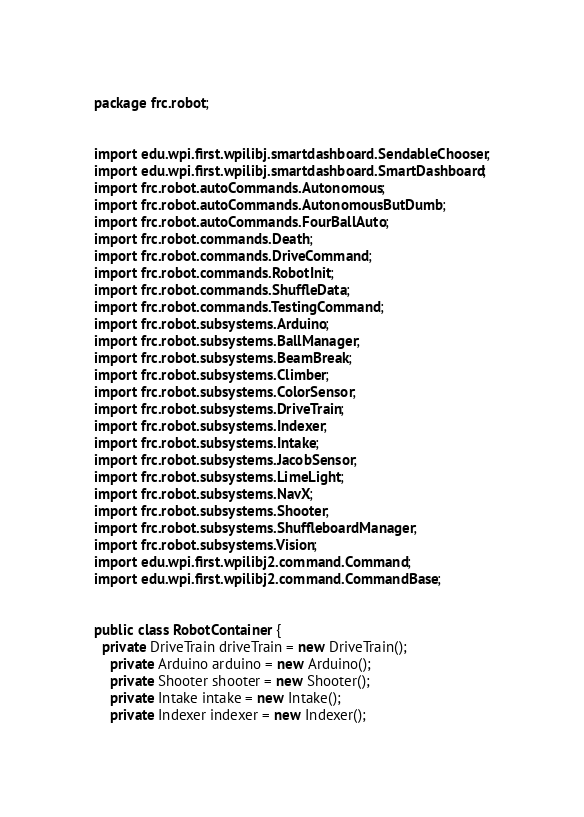Convert code to text. <code><loc_0><loc_0><loc_500><loc_500><_Java_>package frc.robot;


import edu.wpi.first.wpilibj.smartdashboard.SendableChooser;
import edu.wpi.first.wpilibj.smartdashboard.SmartDashboard;
import frc.robot.autoCommands.Autonomous;
import frc.robot.autoCommands.AutonomousButDumb;
import frc.robot.autoCommands.FourBallAuto;
import frc.robot.commands.Death;
import frc.robot.commands.DriveCommand;
import frc.robot.commands.RobotInit;
import frc.robot.commands.ShuffleData;
import frc.robot.commands.TestingCommand;
import frc.robot.subsystems.Arduino;
import frc.robot.subsystems.BallManager;
import frc.robot.subsystems.BeamBreak;
import frc.robot.subsystems.Climber;
import frc.robot.subsystems.ColorSensor;
import frc.robot.subsystems.DriveTrain;
import frc.robot.subsystems.Indexer;
import frc.robot.subsystems.Intake;
import frc.robot.subsystems.JacobSensor;
import frc.robot.subsystems.LimeLight;
import frc.robot.subsystems.NavX;
import frc.robot.subsystems.Shooter;
import frc.robot.subsystems.ShuffleboardManager;
import frc.robot.subsystems.Vision;
import edu.wpi.first.wpilibj2.command.Command;
import edu.wpi.first.wpilibj2.command.CommandBase;


public class RobotContainer {
  private DriveTrain driveTrain = new DriveTrain();
    private Arduino arduino = new Arduino();
    private Shooter shooter = new Shooter();
    private Intake intake = new Intake();
    private Indexer indexer = new Indexer();</code> 